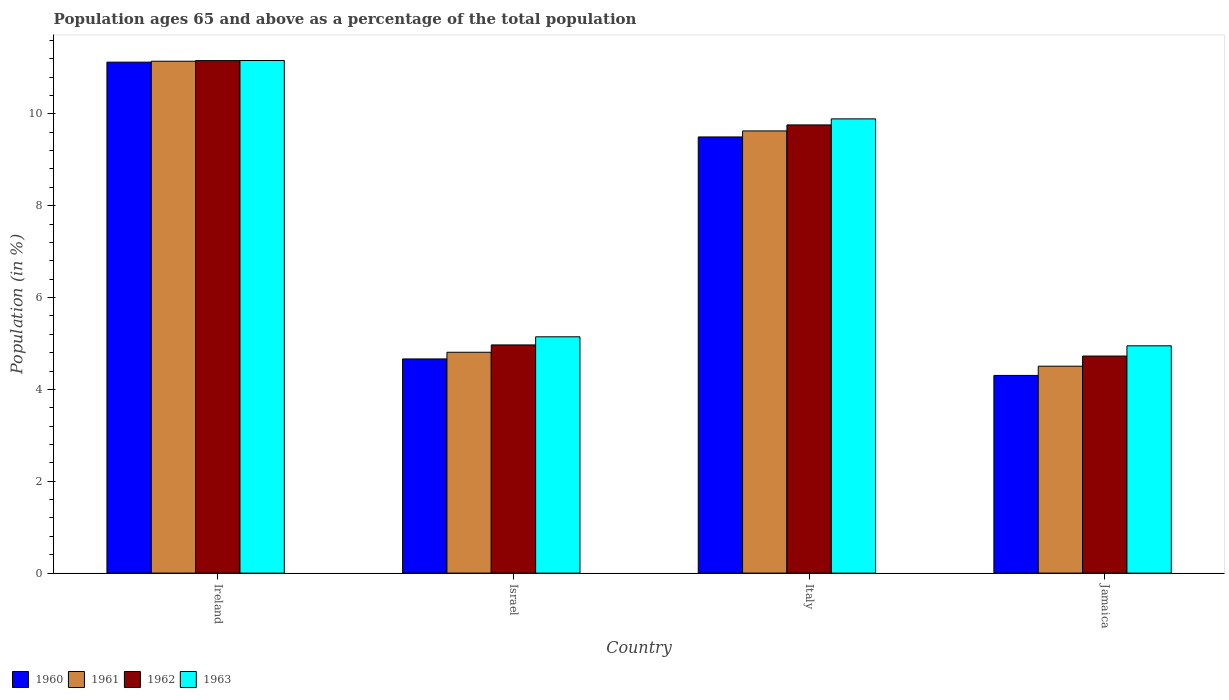Are the number of bars on each tick of the X-axis equal?
Your answer should be very brief. Yes. How many bars are there on the 3rd tick from the left?
Your response must be concise. 4. What is the label of the 4th group of bars from the left?
Your answer should be very brief. Jamaica. What is the percentage of the population ages 65 and above in 1960 in Ireland?
Your answer should be compact. 11.12. Across all countries, what is the maximum percentage of the population ages 65 and above in 1963?
Keep it short and to the point. 11.16. Across all countries, what is the minimum percentage of the population ages 65 and above in 1960?
Provide a short and direct response. 4.3. In which country was the percentage of the population ages 65 and above in 1961 maximum?
Your response must be concise. Ireland. In which country was the percentage of the population ages 65 and above in 1960 minimum?
Your answer should be very brief. Jamaica. What is the total percentage of the population ages 65 and above in 1960 in the graph?
Ensure brevity in your answer.  29.59. What is the difference between the percentage of the population ages 65 and above in 1961 in Italy and that in Jamaica?
Your response must be concise. 5.12. What is the difference between the percentage of the population ages 65 and above in 1962 in Italy and the percentage of the population ages 65 and above in 1960 in Jamaica?
Make the answer very short. 5.45. What is the average percentage of the population ages 65 and above in 1960 per country?
Offer a very short reply. 7.4. What is the difference between the percentage of the population ages 65 and above of/in 1961 and percentage of the population ages 65 and above of/in 1960 in Ireland?
Provide a short and direct response. 0.02. In how many countries, is the percentage of the population ages 65 and above in 1962 greater than 2?
Give a very brief answer. 4. What is the ratio of the percentage of the population ages 65 and above in 1961 in Ireland to that in Jamaica?
Make the answer very short. 2.47. Is the difference between the percentage of the population ages 65 and above in 1961 in Ireland and Israel greater than the difference between the percentage of the population ages 65 and above in 1960 in Ireland and Israel?
Your answer should be compact. No. What is the difference between the highest and the second highest percentage of the population ages 65 and above in 1962?
Keep it short and to the point. -1.4. What is the difference between the highest and the lowest percentage of the population ages 65 and above in 1962?
Offer a very short reply. 6.43. In how many countries, is the percentage of the population ages 65 and above in 1960 greater than the average percentage of the population ages 65 and above in 1960 taken over all countries?
Offer a terse response. 2. Is the sum of the percentage of the population ages 65 and above in 1963 in Ireland and Italy greater than the maximum percentage of the population ages 65 and above in 1960 across all countries?
Provide a succinct answer. Yes. Is it the case that in every country, the sum of the percentage of the population ages 65 and above in 1960 and percentage of the population ages 65 and above in 1961 is greater than the sum of percentage of the population ages 65 and above in 1962 and percentage of the population ages 65 and above in 1963?
Your answer should be very brief. No. What does the 2nd bar from the right in Israel represents?
Give a very brief answer. 1962. How many bars are there?
Your answer should be very brief. 16. Are all the bars in the graph horizontal?
Provide a short and direct response. No. How many legend labels are there?
Your answer should be compact. 4. What is the title of the graph?
Offer a very short reply. Population ages 65 and above as a percentage of the total population. Does "2008" appear as one of the legend labels in the graph?
Make the answer very short. No. What is the Population (in %) of 1960 in Ireland?
Give a very brief answer. 11.12. What is the Population (in %) in 1961 in Ireland?
Provide a short and direct response. 11.14. What is the Population (in %) in 1962 in Ireland?
Give a very brief answer. 11.16. What is the Population (in %) in 1963 in Ireland?
Your response must be concise. 11.16. What is the Population (in %) of 1960 in Israel?
Offer a very short reply. 4.66. What is the Population (in %) of 1961 in Israel?
Your response must be concise. 4.81. What is the Population (in %) in 1962 in Israel?
Provide a short and direct response. 4.97. What is the Population (in %) of 1963 in Israel?
Offer a very short reply. 5.14. What is the Population (in %) of 1960 in Italy?
Provide a succinct answer. 9.5. What is the Population (in %) of 1961 in Italy?
Keep it short and to the point. 9.63. What is the Population (in %) of 1962 in Italy?
Give a very brief answer. 9.76. What is the Population (in %) in 1963 in Italy?
Your answer should be very brief. 9.89. What is the Population (in %) of 1960 in Jamaica?
Your response must be concise. 4.3. What is the Population (in %) in 1961 in Jamaica?
Keep it short and to the point. 4.5. What is the Population (in %) of 1962 in Jamaica?
Offer a terse response. 4.73. What is the Population (in %) in 1963 in Jamaica?
Ensure brevity in your answer.  4.95. Across all countries, what is the maximum Population (in %) in 1960?
Offer a terse response. 11.12. Across all countries, what is the maximum Population (in %) in 1961?
Your answer should be compact. 11.14. Across all countries, what is the maximum Population (in %) in 1962?
Provide a succinct answer. 11.16. Across all countries, what is the maximum Population (in %) of 1963?
Provide a short and direct response. 11.16. Across all countries, what is the minimum Population (in %) in 1960?
Make the answer very short. 4.3. Across all countries, what is the minimum Population (in %) in 1961?
Ensure brevity in your answer.  4.5. Across all countries, what is the minimum Population (in %) in 1962?
Provide a succinct answer. 4.73. Across all countries, what is the minimum Population (in %) of 1963?
Offer a very short reply. 4.95. What is the total Population (in %) in 1960 in the graph?
Provide a short and direct response. 29.59. What is the total Population (in %) of 1961 in the graph?
Your answer should be compact. 30.08. What is the total Population (in %) of 1962 in the graph?
Provide a succinct answer. 30.61. What is the total Population (in %) of 1963 in the graph?
Ensure brevity in your answer.  31.14. What is the difference between the Population (in %) of 1960 in Ireland and that in Israel?
Your answer should be compact. 6.46. What is the difference between the Population (in %) in 1961 in Ireland and that in Israel?
Offer a terse response. 6.34. What is the difference between the Population (in %) of 1962 in Ireland and that in Israel?
Provide a succinct answer. 6.19. What is the difference between the Population (in %) in 1963 in Ireland and that in Israel?
Your response must be concise. 6.02. What is the difference between the Population (in %) in 1960 in Ireland and that in Italy?
Your answer should be very brief. 1.63. What is the difference between the Population (in %) in 1961 in Ireland and that in Italy?
Provide a short and direct response. 1.52. What is the difference between the Population (in %) in 1962 in Ireland and that in Italy?
Make the answer very short. 1.4. What is the difference between the Population (in %) of 1963 in Ireland and that in Italy?
Offer a terse response. 1.27. What is the difference between the Population (in %) in 1960 in Ireland and that in Jamaica?
Offer a terse response. 6.82. What is the difference between the Population (in %) of 1961 in Ireland and that in Jamaica?
Give a very brief answer. 6.64. What is the difference between the Population (in %) in 1962 in Ireland and that in Jamaica?
Provide a succinct answer. 6.43. What is the difference between the Population (in %) in 1963 in Ireland and that in Jamaica?
Offer a very short reply. 6.21. What is the difference between the Population (in %) in 1960 in Israel and that in Italy?
Your answer should be compact. -4.83. What is the difference between the Population (in %) of 1961 in Israel and that in Italy?
Ensure brevity in your answer.  -4.82. What is the difference between the Population (in %) of 1962 in Israel and that in Italy?
Your response must be concise. -4.79. What is the difference between the Population (in %) in 1963 in Israel and that in Italy?
Your answer should be very brief. -4.75. What is the difference between the Population (in %) in 1960 in Israel and that in Jamaica?
Ensure brevity in your answer.  0.36. What is the difference between the Population (in %) of 1961 in Israel and that in Jamaica?
Your answer should be compact. 0.3. What is the difference between the Population (in %) in 1962 in Israel and that in Jamaica?
Keep it short and to the point. 0.24. What is the difference between the Population (in %) in 1963 in Israel and that in Jamaica?
Make the answer very short. 0.2. What is the difference between the Population (in %) of 1960 in Italy and that in Jamaica?
Give a very brief answer. 5.19. What is the difference between the Population (in %) in 1961 in Italy and that in Jamaica?
Ensure brevity in your answer.  5.12. What is the difference between the Population (in %) in 1962 in Italy and that in Jamaica?
Offer a terse response. 5.03. What is the difference between the Population (in %) in 1963 in Italy and that in Jamaica?
Ensure brevity in your answer.  4.94. What is the difference between the Population (in %) in 1960 in Ireland and the Population (in %) in 1961 in Israel?
Provide a succinct answer. 6.32. What is the difference between the Population (in %) of 1960 in Ireland and the Population (in %) of 1962 in Israel?
Keep it short and to the point. 6.16. What is the difference between the Population (in %) of 1960 in Ireland and the Population (in %) of 1963 in Israel?
Give a very brief answer. 5.98. What is the difference between the Population (in %) of 1961 in Ireland and the Population (in %) of 1962 in Israel?
Provide a succinct answer. 6.18. What is the difference between the Population (in %) of 1961 in Ireland and the Population (in %) of 1963 in Israel?
Make the answer very short. 6. What is the difference between the Population (in %) in 1962 in Ireland and the Population (in %) in 1963 in Israel?
Ensure brevity in your answer.  6.01. What is the difference between the Population (in %) in 1960 in Ireland and the Population (in %) in 1961 in Italy?
Ensure brevity in your answer.  1.5. What is the difference between the Population (in %) in 1960 in Ireland and the Population (in %) in 1962 in Italy?
Offer a very short reply. 1.37. What is the difference between the Population (in %) of 1960 in Ireland and the Population (in %) of 1963 in Italy?
Provide a succinct answer. 1.23. What is the difference between the Population (in %) of 1961 in Ireland and the Population (in %) of 1962 in Italy?
Make the answer very short. 1.39. What is the difference between the Population (in %) of 1961 in Ireland and the Population (in %) of 1963 in Italy?
Give a very brief answer. 1.25. What is the difference between the Population (in %) in 1962 in Ireland and the Population (in %) in 1963 in Italy?
Your answer should be compact. 1.27. What is the difference between the Population (in %) of 1960 in Ireland and the Population (in %) of 1961 in Jamaica?
Offer a terse response. 6.62. What is the difference between the Population (in %) of 1960 in Ireland and the Population (in %) of 1962 in Jamaica?
Give a very brief answer. 6.4. What is the difference between the Population (in %) of 1960 in Ireland and the Population (in %) of 1963 in Jamaica?
Your answer should be very brief. 6.18. What is the difference between the Population (in %) of 1961 in Ireland and the Population (in %) of 1962 in Jamaica?
Keep it short and to the point. 6.42. What is the difference between the Population (in %) of 1961 in Ireland and the Population (in %) of 1963 in Jamaica?
Your answer should be very brief. 6.2. What is the difference between the Population (in %) of 1962 in Ireland and the Population (in %) of 1963 in Jamaica?
Your answer should be compact. 6.21. What is the difference between the Population (in %) in 1960 in Israel and the Population (in %) in 1961 in Italy?
Keep it short and to the point. -4.96. What is the difference between the Population (in %) in 1960 in Israel and the Population (in %) in 1962 in Italy?
Ensure brevity in your answer.  -5.09. What is the difference between the Population (in %) of 1960 in Israel and the Population (in %) of 1963 in Italy?
Your response must be concise. -5.23. What is the difference between the Population (in %) in 1961 in Israel and the Population (in %) in 1962 in Italy?
Your response must be concise. -4.95. What is the difference between the Population (in %) in 1961 in Israel and the Population (in %) in 1963 in Italy?
Your response must be concise. -5.08. What is the difference between the Population (in %) in 1962 in Israel and the Population (in %) in 1963 in Italy?
Provide a succinct answer. -4.92. What is the difference between the Population (in %) of 1960 in Israel and the Population (in %) of 1961 in Jamaica?
Keep it short and to the point. 0.16. What is the difference between the Population (in %) in 1960 in Israel and the Population (in %) in 1962 in Jamaica?
Your response must be concise. -0.06. What is the difference between the Population (in %) in 1960 in Israel and the Population (in %) in 1963 in Jamaica?
Give a very brief answer. -0.29. What is the difference between the Population (in %) in 1961 in Israel and the Population (in %) in 1962 in Jamaica?
Provide a short and direct response. 0.08. What is the difference between the Population (in %) of 1961 in Israel and the Population (in %) of 1963 in Jamaica?
Your response must be concise. -0.14. What is the difference between the Population (in %) in 1962 in Israel and the Population (in %) in 1963 in Jamaica?
Give a very brief answer. 0.02. What is the difference between the Population (in %) in 1960 in Italy and the Population (in %) in 1961 in Jamaica?
Offer a terse response. 4.99. What is the difference between the Population (in %) of 1960 in Italy and the Population (in %) of 1962 in Jamaica?
Ensure brevity in your answer.  4.77. What is the difference between the Population (in %) of 1960 in Italy and the Population (in %) of 1963 in Jamaica?
Offer a very short reply. 4.55. What is the difference between the Population (in %) of 1961 in Italy and the Population (in %) of 1962 in Jamaica?
Offer a very short reply. 4.9. What is the difference between the Population (in %) in 1961 in Italy and the Population (in %) in 1963 in Jamaica?
Your answer should be very brief. 4.68. What is the difference between the Population (in %) of 1962 in Italy and the Population (in %) of 1963 in Jamaica?
Your answer should be compact. 4.81. What is the average Population (in %) in 1960 per country?
Keep it short and to the point. 7.4. What is the average Population (in %) of 1961 per country?
Make the answer very short. 7.52. What is the average Population (in %) in 1962 per country?
Your answer should be very brief. 7.65. What is the average Population (in %) of 1963 per country?
Give a very brief answer. 7.79. What is the difference between the Population (in %) in 1960 and Population (in %) in 1961 in Ireland?
Keep it short and to the point. -0.02. What is the difference between the Population (in %) in 1960 and Population (in %) in 1962 in Ireland?
Keep it short and to the point. -0.03. What is the difference between the Population (in %) in 1960 and Population (in %) in 1963 in Ireland?
Ensure brevity in your answer.  -0.04. What is the difference between the Population (in %) of 1961 and Population (in %) of 1962 in Ireland?
Keep it short and to the point. -0.01. What is the difference between the Population (in %) of 1961 and Population (in %) of 1963 in Ireland?
Offer a terse response. -0.02. What is the difference between the Population (in %) of 1962 and Population (in %) of 1963 in Ireland?
Provide a succinct answer. -0. What is the difference between the Population (in %) of 1960 and Population (in %) of 1961 in Israel?
Offer a very short reply. -0.15. What is the difference between the Population (in %) in 1960 and Population (in %) in 1962 in Israel?
Offer a terse response. -0.3. What is the difference between the Population (in %) of 1960 and Population (in %) of 1963 in Israel?
Offer a very short reply. -0.48. What is the difference between the Population (in %) of 1961 and Population (in %) of 1962 in Israel?
Your answer should be very brief. -0.16. What is the difference between the Population (in %) of 1961 and Population (in %) of 1963 in Israel?
Keep it short and to the point. -0.34. What is the difference between the Population (in %) of 1962 and Population (in %) of 1963 in Israel?
Provide a short and direct response. -0.18. What is the difference between the Population (in %) of 1960 and Population (in %) of 1961 in Italy?
Your answer should be very brief. -0.13. What is the difference between the Population (in %) of 1960 and Population (in %) of 1962 in Italy?
Keep it short and to the point. -0.26. What is the difference between the Population (in %) in 1960 and Population (in %) in 1963 in Italy?
Give a very brief answer. -0.39. What is the difference between the Population (in %) of 1961 and Population (in %) of 1962 in Italy?
Give a very brief answer. -0.13. What is the difference between the Population (in %) of 1961 and Population (in %) of 1963 in Italy?
Your answer should be very brief. -0.26. What is the difference between the Population (in %) in 1962 and Population (in %) in 1963 in Italy?
Offer a very short reply. -0.13. What is the difference between the Population (in %) in 1960 and Population (in %) in 1961 in Jamaica?
Your answer should be compact. -0.2. What is the difference between the Population (in %) of 1960 and Population (in %) of 1962 in Jamaica?
Make the answer very short. -0.42. What is the difference between the Population (in %) of 1960 and Population (in %) of 1963 in Jamaica?
Give a very brief answer. -0.65. What is the difference between the Population (in %) of 1961 and Population (in %) of 1962 in Jamaica?
Your answer should be compact. -0.22. What is the difference between the Population (in %) in 1961 and Population (in %) in 1963 in Jamaica?
Make the answer very short. -0.44. What is the difference between the Population (in %) in 1962 and Population (in %) in 1963 in Jamaica?
Your response must be concise. -0.22. What is the ratio of the Population (in %) of 1960 in Ireland to that in Israel?
Give a very brief answer. 2.39. What is the ratio of the Population (in %) in 1961 in Ireland to that in Israel?
Offer a terse response. 2.32. What is the ratio of the Population (in %) of 1962 in Ireland to that in Israel?
Provide a succinct answer. 2.25. What is the ratio of the Population (in %) in 1963 in Ireland to that in Israel?
Your response must be concise. 2.17. What is the ratio of the Population (in %) of 1960 in Ireland to that in Italy?
Offer a very short reply. 1.17. What is the ratio of the Population (in %) in 1961 in Ireland to that in Italy?
Your answer should be compact. 1.16. What is the ratio of the Population (in %) of 1962 in Ireland to that in Italy?
Provide a short and direct response. 1.14. What is the ratio of the Population (in %) of 1963 in Ireland to that in Italy?
Give a very brief answer. 1.13. What is the ratio of the Population (in %) in 1960 in Ireland to that in Jamaica?
Give a very brief answer. 2.58. What is the ratio of the Population (in %) in 1961 in Ireland to that in Jamaica?
Keep it short and to the point. 2.47. What is the ratio of the Population (in %) in 1962 in Ireland to that in Jamaica?
Offer a very short reply. 2.36. What is the ratio of the Population (in %) of 1963 in Ireland to that in Jamaica?
Offer a very short reply. 2.26. What is the ratio of the Population (in %) of 1960 in Israel to that in Italy?
Offer a very short reply. 0.49. What is the ratio of the Population (in %) of 1961 in Israel to that in Italy?
Provide a succinct answer. 0.5. What is the ratio of the Population (in %) of 1962 in Israel to that in Italy?
Provide a succinct answer. 0.51. What is the ratio of the Population (in %) of 1963 in Israel to that in Italy?
Your response must be concise. 0.52. What is the ratio of the Population (in %) of 1960 in Israel to that in Jamaica?
Your answer should be very brief. 1.08. What is the ratio of the Population (in %) in 1961 in Israel to that in Jamaica?
Give a very brief answer. 1.07. What is the ratio of the Population (in %) of 1962 in Israel to that in Jamaica?
Make the answer very short. 1.05. What is the ratio of the Population (in %) of 1963 in Israel to that in Jamaica?
Your answer should be compact. 1.04. What is the ratio of the Population (in %) of 1960 in Italy to that in Jamaica?
Give a very brief answer. 2.21. What is the ratio of the Population (in %) of 1961 in Italy to that in Jamaica?
Offer a very short reply. 2.14. What is the ratio of the Population (in %) in 1962 in Italy to that in Jamaica?
Your answer should be very brief. 2.06. What is the ratio of the Population (in %) in 1963 in Italy to that in Jamaica?
Make the answer very short. 2. What is the difference between the highest and the second highest Population (in %) in 1960?
Provide a succinct answer. 1.63. What is the difference between the highest and the second highest Population (in %) of 1961?
Your response must be concise. 1.52. What is the difference between the highest and the second highest Population (in %) in 1962?
Your response must be concise. 1.4. What is the difference between the highest and the second highest Population (in %) in 1963?
Offer a very short reply. 1.27. What is the difference between the highest and the lowest Population (in %) in 1960?
Keep it short and to the point. 6.82. What is the difference between the highest and the lowest Population (in %) of 1961?
Offer a very short reply. 6.64. What is the difference between the highest and the lowest Population (in %) in 1962?
Offer a very short reply. 6.43. What is the difference between the highest and the lowest Population (in %) in 1963?
Your answer should be very brief. 6.21. 